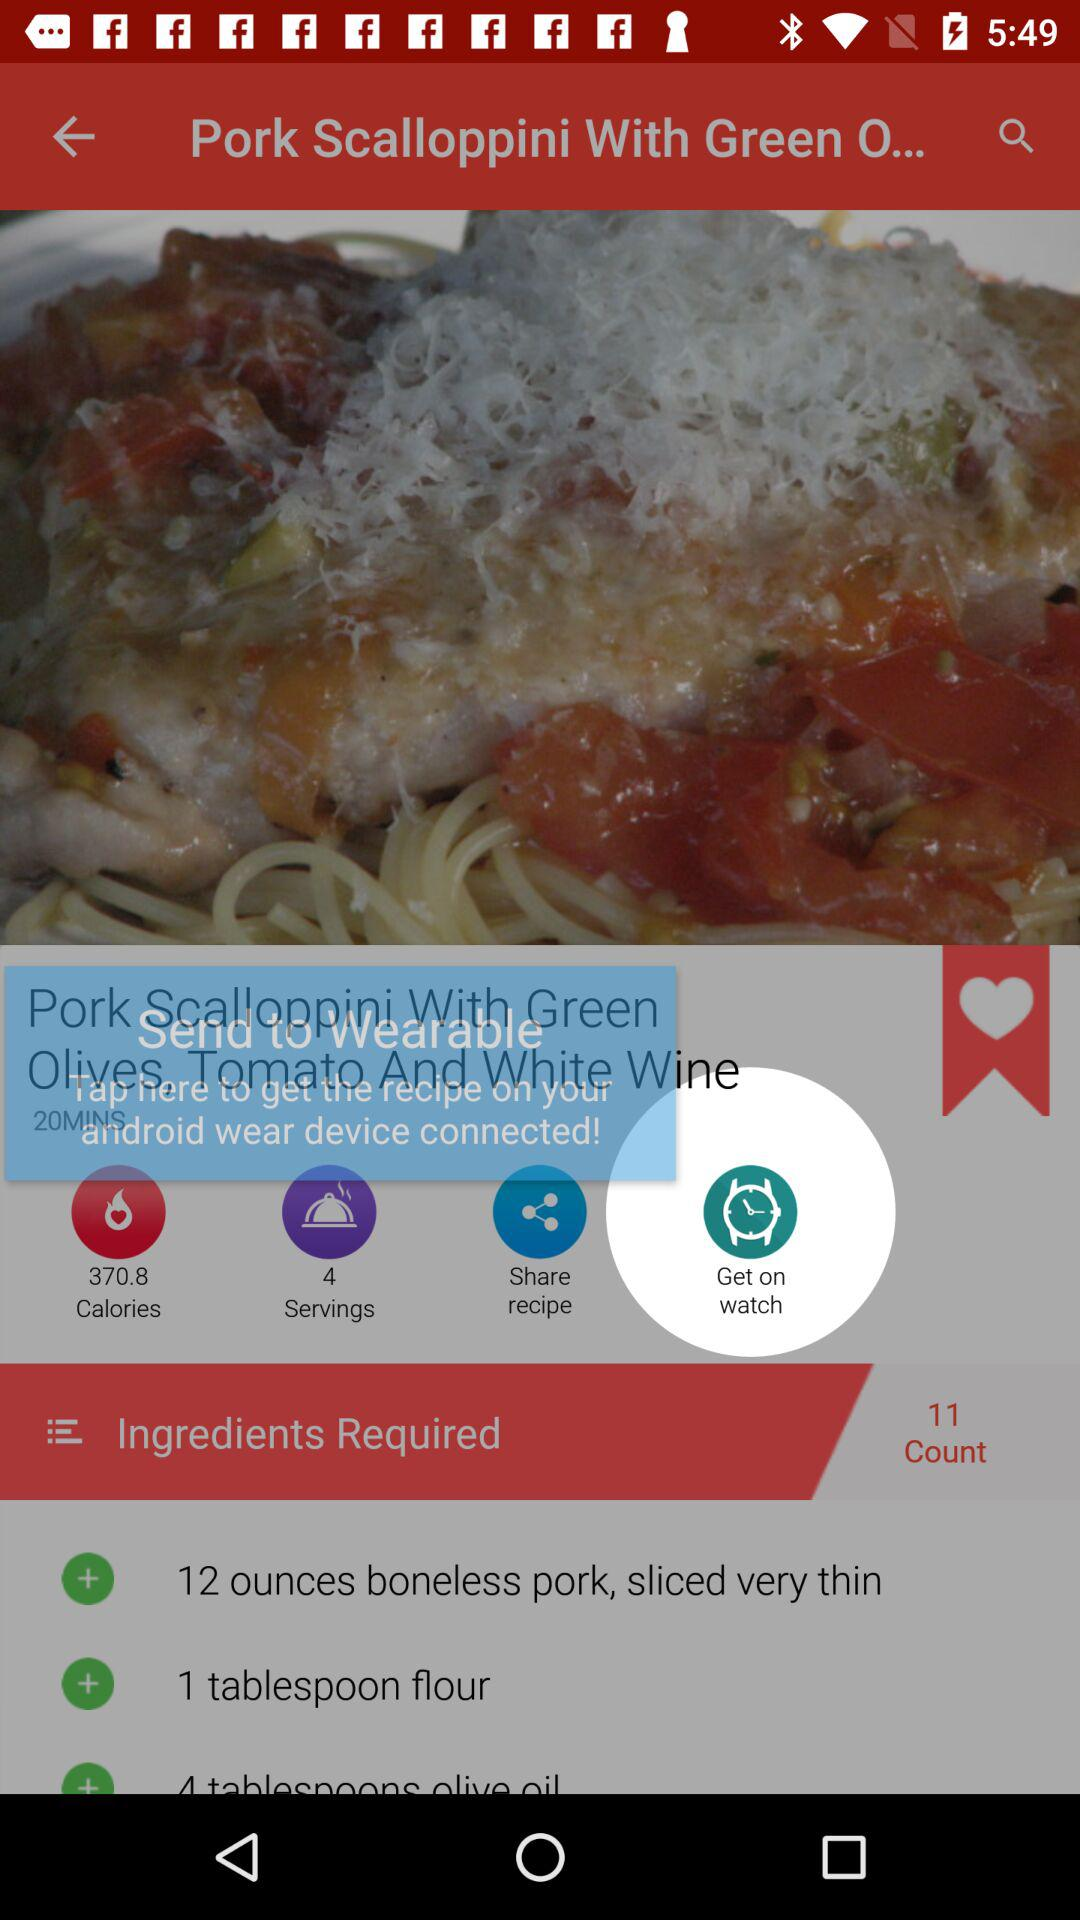How many calories are there? There are 370.8 calories. 